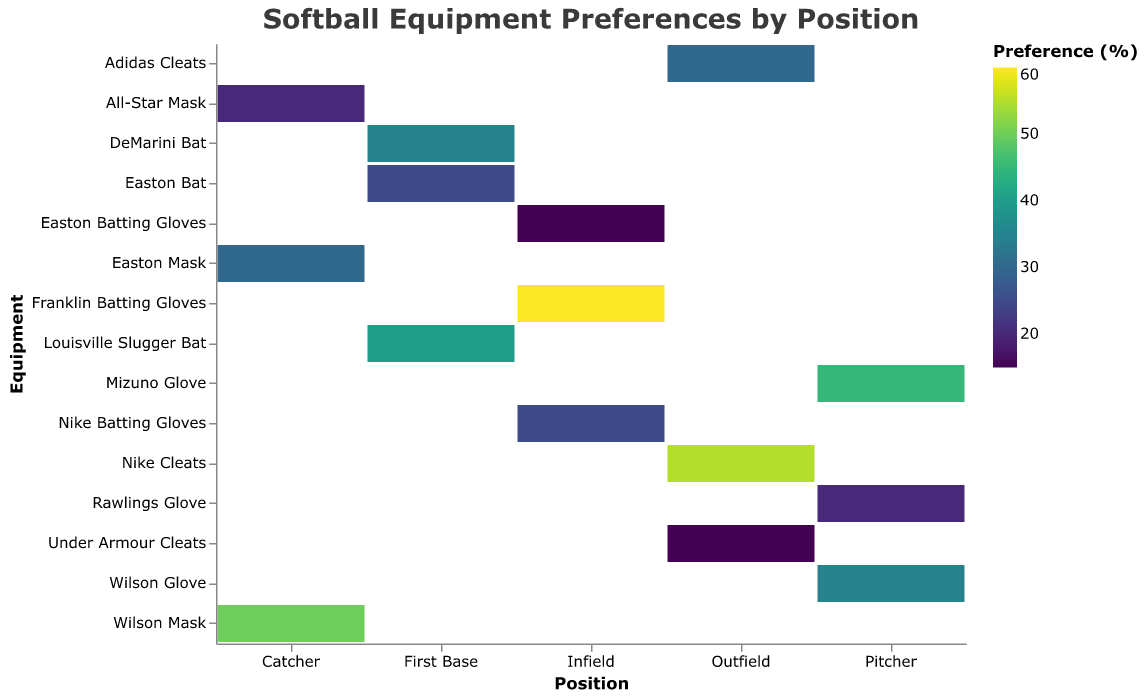what is the title of the plot? The title is usually at the top of the plot, which summarizes what the plot is about.
Answer: Softball Equipment Preferences by Position What equipment do outfielders prefer the most? Look at the outfielders category on the x-axis and identify the equipment with the highest preference.
Answer: Nike Cleats What is the percentage preference for Rawlings Glove among pitchers? Look at the Pitcher category on the x-axis and find the Rawlings Glove value.
Answer: 20% Which position has the highest preference for Adidas Cleats? Look for Adidas Cleats on the y-axis and determine its highest value across different positions.
Answer: Outfield How does the preference for Franklin Batting Gloves compare to Nike Batting Gloves among infielders? Check the preference values for both Franklin Batting Gloves and Nike Batting Gloves under the Infield category. Compare the two values.
Answer: Franklin Batting Gloves have a higher preference (60%) than Nike Batting Gloves (25%) Which position has the least preference for All-Star Mask? Identify the preference values for All-Star Mask among all relevant positions and choose the position with the lowest preference.
Answer: Catcher What is the sum of preferences for all three types of gloves among pitchers? Add up the preferences for Mizuno Glove (45), Wilson Glove (35), and Rawlings Glove (20) for pitchers.
Answer: 100% Which equipment has the lowest overall preference across all positions? Look for the smallest number in the color spectrum across all the categories.
Answer: Under Armour Cleats Compare the preference for Louisville Slugger Bat versus DeMarini Bat among first basemen. Look for preferences values for both Louisville Slugger Bat (40) and DeMarini Bat (35) under the First Base category and compare them.
Answer: Louisville Slugger Bat is preferred more (40%) than DeMarini Bat (35%) Which piece of equipment has the highest preference in the entire dataset? Identify the equipment with the darkest color (highest value) on the plot.
Answer: Franklin Batting Gloves Calculate the average preference for masks among catchers. Add the preferences for Wilson Mask (50), Easton Mask (30), and All-Star Mask (20) and divide by the number of equipment types (3).
Answer: 33.33% 